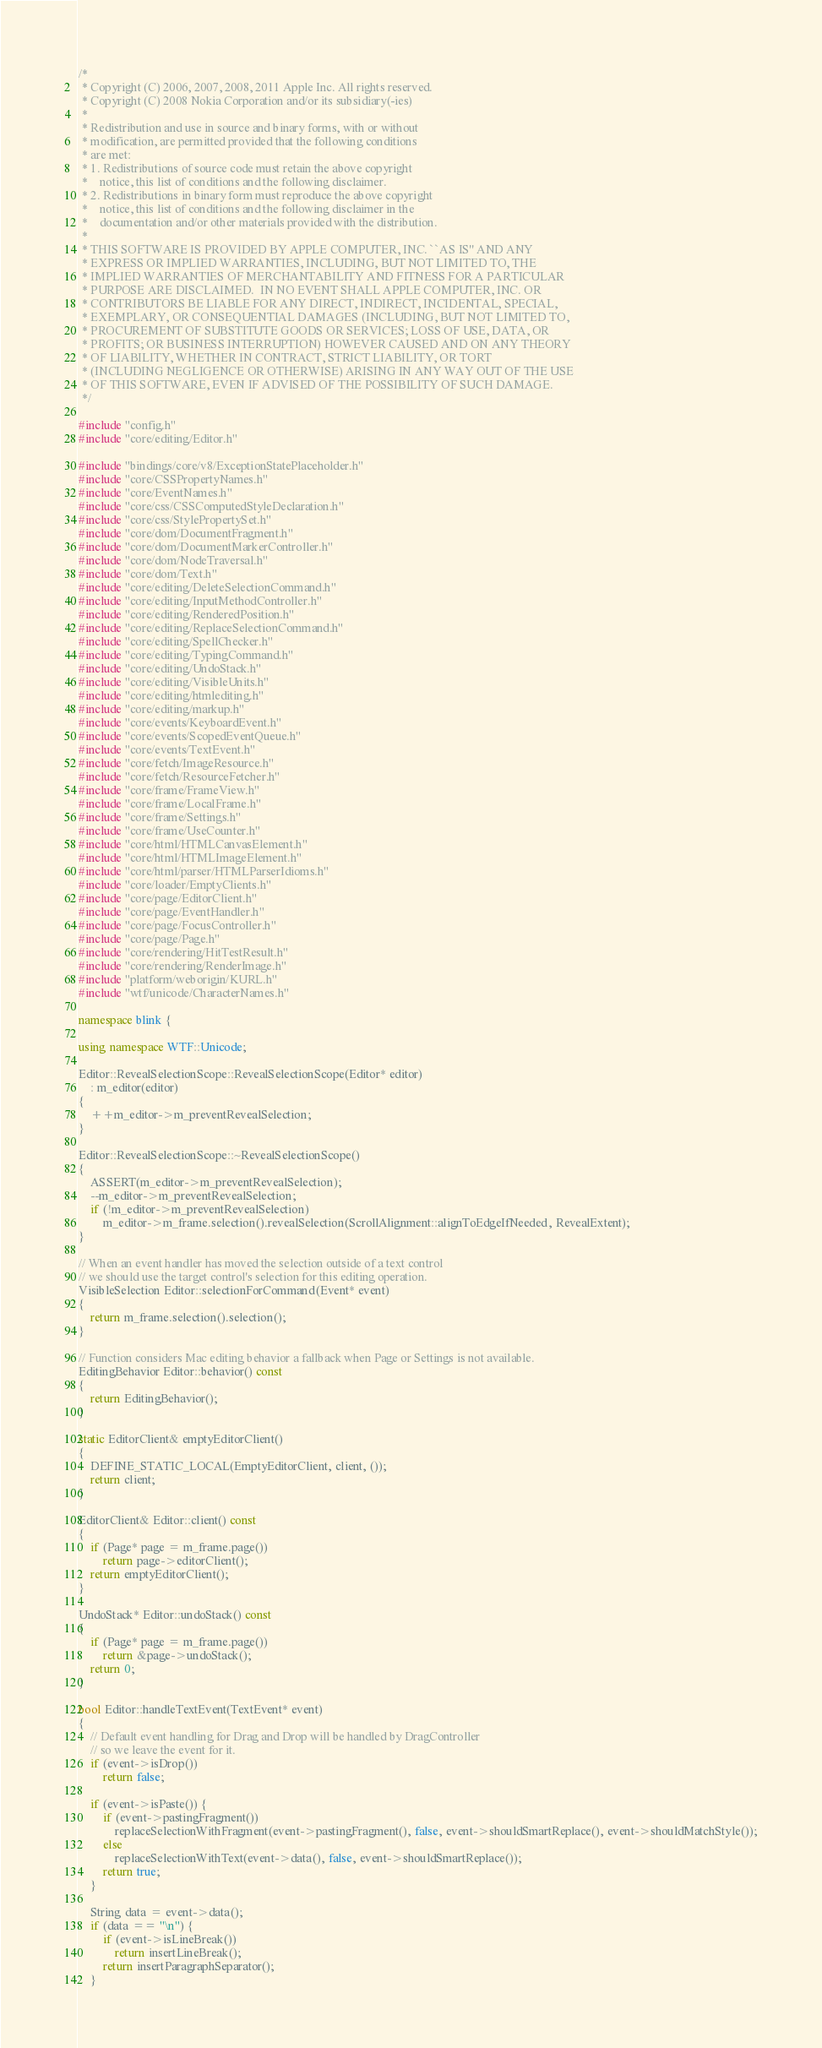<code> <loc_0><loc_0><loc_500><loc_500><_C++_>/*
 * Copyright (C) 2006, 2007, 2008, 2011 Apple Inc. All rights reserved.
 * Copyright (C) 2008 Nokia Corporation and/or its subsidiary(-ies)
 *
 * Redistribution and use in source and binary forms, with or without
 * modification, are permitted provided that the following conditions
 * are met:
 * 1. Redistributions of source code must retain the above copyright
 *    notice, this list of conditions and the following disclaimer.
 * 2. Redistributions in binary form must reproduce the above copyright
 *    notice, this list of conditions and the following disclaimer in the
 *    documentation and/or other materials provided with the distribution.
 *
 * THIS SOFTWARE IS PROVIDED BY APPLE COMPUTER, INC. ``AS IS'' AND ANY
 * EXPRESS OR IMPLIED WARRANTIES, INCLUDING, BUT NOT LIMITED TO, THE
 * IMPLIED WARRANTIES OF MERCHANTABILITY AND FITNESS FOR A PARTICULAR
 * PURPOSE ARE DISCLAIMED.  IN NO EVENT SHALL APPLE COMPUTER, INC. OR
 * CONTRIBUTORS BE LIABLE FOR ANY DIRECT, INDIRECT, INCIDENTAL, SPECIAL,
 * EXEMPLARY, OR CONSEQUENTIAL DAMAGES (INCLUDING, BUT NOT LIMITED TO,
 * PROCUREMENT OF SUBSTITUTE GOODS OR SERVICES; LOSS OF USE, DATA, OR
 * PROFITS; OR BUSINESS INTERRUPTION) HOWEVER CAUSED AND ON ANY THEORY
 * OF LIABILITY, WHETHER IN CONTRACT, STRICT LIABILITY, OR TORT
 * (INCLUDING NEGLIGENCE OR OTHERWISE) ARISING IN ANY WAY OUT OF THE USE
 * OF THIS SOFTWARE, EVEN IF ADVISED OF THE POSSIBILITY OF SUCH DAMAGE.
 */

#include "config.h"
#include "core/editing/Editor.h"

#include "bindings/core/v8/ExceptionStatePlaceholder.h"
#include "core/CSSPropertyNames.h"
#include "core/EventNames.h"
#include "core/css/CSSComputedStyleDeclaration.h"
#include "core/css/StylePropertySet.h"
#include "core/dom/DocumentFragment.h"
#include "core/dom/DocumentMarkerController.h"
#include "core/dom/NodeTraversal.h"
#include "core/dom/Text.h"
#include "core/editing/DeleteSelectionCommand.h"
#include "core/editing/InputMethodController.h"
#include "core/editing/RenderedPosition.h"
#include "core/editing/ReplaceSelectionCommand.h"
#include "core/editing/SpellChecker.h"
#include "core/editing/TypingCommand.h"
#include "core/editing/UndoStack.h"
#include "core/editing/VisibleUnits.h"
#include "core/editing/htmlediting.h"
#include "core/editing/markup.h"
#include "core/events/KeyboardEvent.h"
#include "core/events/ScopedEventQueue.h"
#include "core/events/TextEvent.h"
#include "core/fetch/ImageResource.h"
#include "core/fetch/ResourceFetcher.h"
#include "core/frame/FrameView.h"
#include "core/frame/LocalFrame.h"
#include "core/frame/Settings.h"
#include "core/frame/UseCounter.h"
#include "core/html/HTMLCanvasElement.h"
#include "core/html/HTMLImageElement.h"
#include "core/html/parser/HTMLParserIdioms.h"
#include "core/loader/EmptyClients.h"
#include "core/page/EditorClient.h"
#include "core/page/EventHandler.h"
#include "core/page/FocusController.h"
#include "core/page/Page.h"
#include "core/rendering/HitTestResult.h"
#include "core/rendering/RenderImage.h"
#include "platform/weborigin/KURL.h"
#include "wtf/unicode/CharacterNames.h"

namespace blink {

using namespace WTF::Unicode;

Editor::RevealSelectionScope::RevealSelectionScope(Editor* editor)
    : m_editor(editor)
{
    ++m_editor->m_preventRevealSelection;
}

Editor::RevealSelectionScope::~RevealSelectionScope()
{
    ASSERT(m_editor->m_preventRevealSelection);
    --m_editor->m_preventRevealSelection;
    if (!m_editor->m_preventRevealSelection)
        m_editor->m_frame.selection().revealSelection(ScrollAlignment::alignToEdgeIfNeeded, RevealExtent);
}

// When an event handler has moved the selection outside of a text control
// we should use the target control's selection for this editing operation.
VisibleSelection Editor::selectionForCommand(Event* event)
{
    return m_frame.selection().selection();
}

// Function considers Mac editing behavior a fallback when Page or Settings is not available.
EditingBehavior Editor::behavior() const
{
    return EditingBehavior();
}

static EditorClient& emptyEditorClient()
{
    DEFINE_STATIC_LOCAL(EmptyEditorClient, client, ());
    return client;
}

EditorClient& Editor::client() const
{
    if (Page* page = m_frame.page())
        return page->editorClient();
    return emptyEditorClient();
}

UndoStack* Editor::undoStack() const
{
    if (Page* page = m_frame.page())
        return &page->undoStack();
    return 0;
}

bool Editor::handleTextEvent(TextEvent* event)
{
    // Default event handling for Drag and Drop will be handled by DragController
    // so we leave the event for it.
    if (event->isDrop())
        return false;

    if (event->isPaste()) {
        if (event->pastingFragment())
            replaceSelectionWithFragment(event->pastingFragment(), false, event->shouldSmartReplace(), event->shouldMatchStyle());
        else
            replaceSelectionWithText(event->data(), false, event->shouldSmartReplace());
        return true;
    }

    String data = event->data();
    if (data == "\n") {
        if (event->isLineBreak())
            return insertLineBreak();
        return insertParagraphSeparator();
    }
</code> 